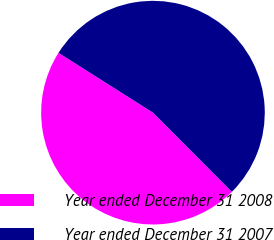Convert chart. <chart><loc_0><loc_0><loc_500><loc_500><pie_chart><fcel>Year ended December 31 2008<fcel>Year ended December 31 2007<nl><fcel>46.46%<fcel>53.54%<nl></chart> 